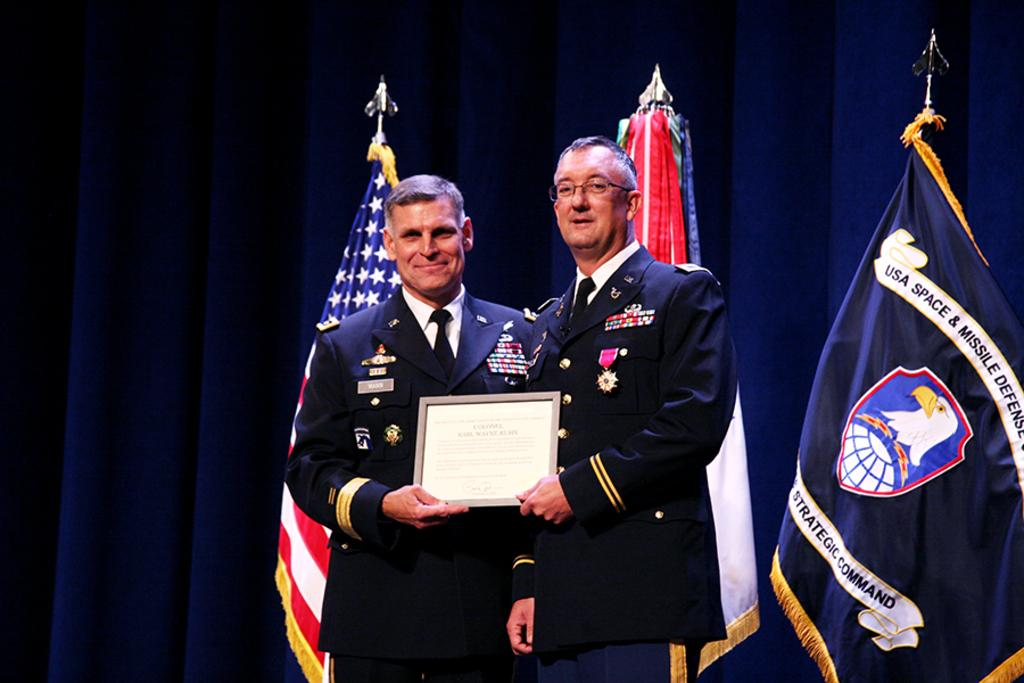Provide a one-sentence caption for the provided image. Two patriots posing for a picture with a flag for the USA Space & Missile Defense in the background. 